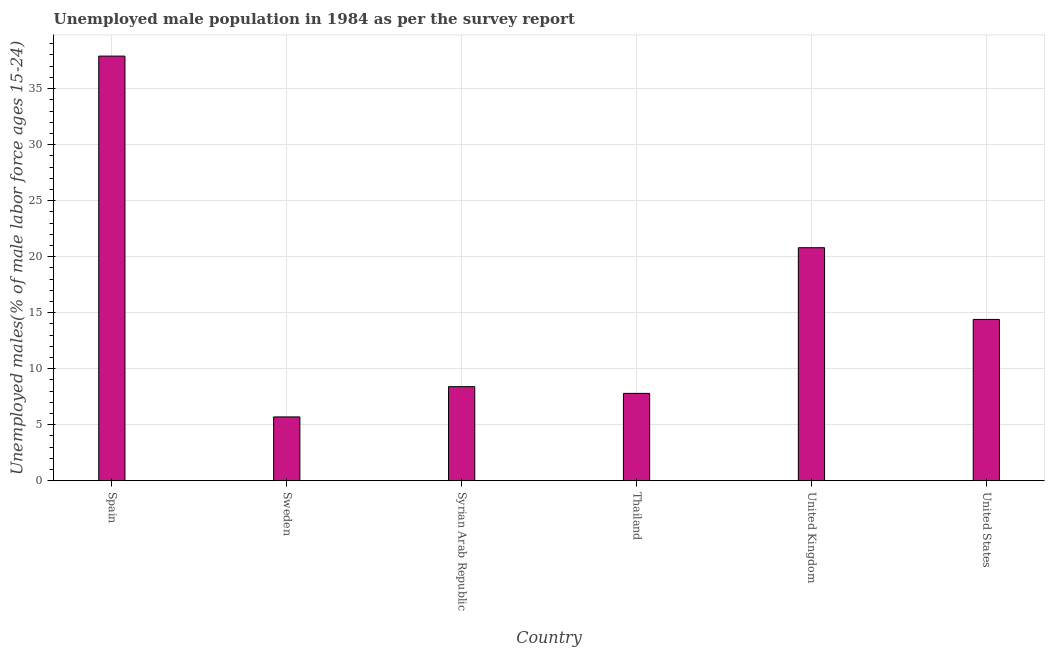Does the graph contain grids?
Offer a very short reply. Yes. What is the title of the graph?
Your response must be concise. Unemployed male population in 1984 as per the survey report. What is the label or title of the X-axis?
Offer a terse response. Country. What is the label or title of the Y-axis?
Your answer should be very brief. Unemployed males(% of male labor force ages 15-24). What is the unemployed male youth in United States?
Your answer should be compact. 14.4. Across all countries, what is the maximum unemployed male youth?
Your response must be concise. 37.9. Across all countries, what is the minimum unemployed male youth?
Your answer should be compact. 5.7. In which country was the unemployed male youth maximum?
Give a very brief answer. Spain. What is the sum of the unemployed male youth?
Your response must be concise. 95. What is the difference between the unemployed male youth in Spain and United States?
Give a very brief answer. 23.5. What is the average unemployed male youth per country?
Keep it short and to the point. 15.83. What is the median unemployed male youth?
Offer a very short reply. 11.4. What is the ratio of the unemployed male youth in Spain to that in United States?
Make the answer very short. 2.63. Is the unemployed male youth in Syrian Arab Republic less than that in Thailand?
Give a very brief answer. No. Is the difference between the unemployed male youth in United Kingdom and United States greater than the difference between any two countries?
Your answer should be very brief. No. Is the sum of the unemployed male youth in Spain and Sweden greater than the maximum unemployed male youth across all countries?
Provide a short and direct response. Yes. What is the difference between the highest and the lowest unemployed male youth?
Provide a succinct answer. 32.2. In how many countries, is the unemployed male youth greater than the average unemployed male youth taken over all countries?
Your answer should be very brief. 2. How many countries are there in the graph?
Your response must be concise. 6. What is the Unemployed males(% of male labor force ages 15-24) of Spain?
Your answer should be compact. 37.9. What is the Unemployed males(% of male labor force ages 15-24) in Sweden?
Provide a succinct answer. 5.7. What is the Unemployed males(% of male labor force ages 15-24) of Syrian Arab Republic?
Keep it short and to the point. 8.4. What is the Unemployed males(% of male labor force ages 15-24) of Thailand?
Keep it short and to the point. 7.8. What is the Unemployed males(% of male labor force ages 15-24) of United Kingdom?
Your answer should be compact. 20.8. What is the Unemployed males(% of male labor force ages 15-24) of United States?
Provide a succinct answer. 14.4. What is the difference between the Unemployed males(% of male labor force ages 15-24) in Spain and Sweden?
Provide a short and direct response. 32.2. What is the difference between the Unemployed males(% of male labor force ages 15-24) in Spain and Syrian Arab Republic?
Your response must be concise. 29.5. What is the difference between the Unemployed males(% of male labor force ages 15-24) in Spain and Thailand?
Your answer should be compact. 30.1. What is the difference between the Unemployed males(% of male labor force ages 15-24) in Spain and United Kingdom?
Your response must be concise. 17.1. What is the difference between the Unemployed males(% of male labor force ages 15-24) in Spain and United States?
Provide a succinct answer. 23.5. What is the difference between the Unemployed males(% of male labor force ages 15-24) in Sweden and Syrian Arab Republic?
Ensure brevity in your answer.  -2.7. What is the difference between the Unemployed males(% of male labor force ages 15-24) in Sweden and United Kingdom?
Your answer should be compact. -15.1. What is the difference between the Unemployed males(% of male labor force ages 15-24) in Sweden and United States?
Provide a succinct answer. -8.7. What is the difference between the Unemployed males(% of male labor force ages 15-24) in Syrian Arab Republic and United Kingdom?
Keep it short and to the point. -12.4. What is the ratio of the Unemployed males(% of male labor force ages 15-24) in Spain to that in Sweden?
Your answer should be very brief. 6.65. What is the ratio of the Unemployed males(% of male labor force ages 15-24) in Spain to that in Syrian Arab Republic?
Ensure brevity in your answer.  4.51. What is the ratio of the Unemployed males(% of male labor force ages 15-24) in Spain to that in Thailand?
Offer a terse response. 4.86. What is the ratio of the Unemployed males(% of male labor force ages 15-24) in Spain to that in United Kingdom?
Keep it short and to the point. 1.82. What is the ratio of the Unemployed males(% of male labor force ages 15-24) in Spain to that in United States?
Give a very brief answer. 2.63. What is the ratio of the Unemployed males(% of male labor force ages 15-24) in Sweden to that in Syrian Arab Republic?
Your answer should be compact. 0.68. What is the ratio of the Unemployed males(% of male labor force ages 15-24) in Sweden to that in Thailand?
Offer a very short reply. 0.73. What is the ratio of the Unemployed males(% of male labor force ages 15-24) in Sweden to that in United Kingdom?
Your answer should be compact. 0.27. What is the ratio of the Unemployed males(% of male labor force ages 15-24) in Sweden to that in United States?
Provide a short and direct response. 0.4. What is the ratio of the Unemployed males(% of male labor force ages 15-24) in Syrian Arab Republic to that in Thailand?
Your answer should be compact. 1.08. What is the ratio of the Unemployed males(% of male labor force ages 15-24) in Syrian Arab Republic to that in United Kingdom?
Your response must be concise. 0.4. What is the ratio of the Unemployed males(% of male labor force ages 15-24) in Syrian Arab Republic to that in United States?
Keep it short and to the point. 0.58. What is the ratio of the Unemployed males(% of male labor force ages 15-24) in Thailand to that in United Kingdom?
Your answer should be very brief. 0.38. What is the ratio of the Unemployed males(% of male labor force ages 15-24) in Thailand to that in United States?
Give a very brief answer. 0.54. What is the ratio of the Unemployed males(% of male labor force ages 15-24) in United Kingdom to that in United States?
Your answer should be very brief. 1.44. 